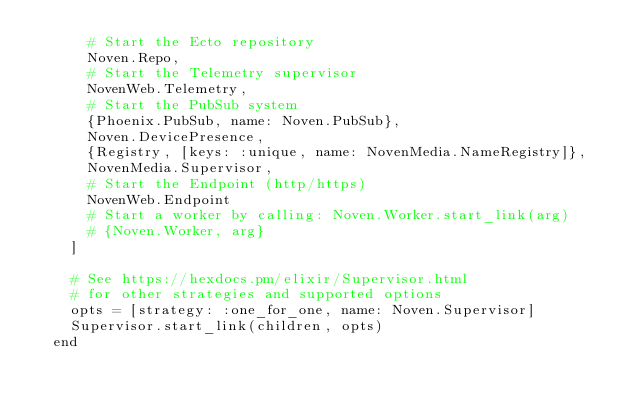Convert code to text. <code><loc_0><loc_0><loc_500><loc_500><_Elixir_>      # Start the Ecto repository
      Noven.Repo,
      # Start the Telemetry supervisor
      NovenWeb.Telemetry,
      # Start the PubSub system
      {Phoenix.PubSub, name: Noven.PubSub},
      Noven.DevicePresence,
      {Registry, [keys: :unique, name: NovenMedia.NameRegistry]},
      NovenMedia.Supervisor,
      # Start the Endpoint (http/https)
      NovenWeb.Endpoint
      # Start a worker by calling: Noven.Worker.start_link(arg)
      # {Noven.Worker, arg}
    ]

    # See https://hexdocs.pm/elixir/Supervisor.html
    # for other strategies and supported options
    opts = [strategy: :one_for_one, name: Noven.Supervisor]
    Supervisor.start_link(children, opts)
  end
</code> 